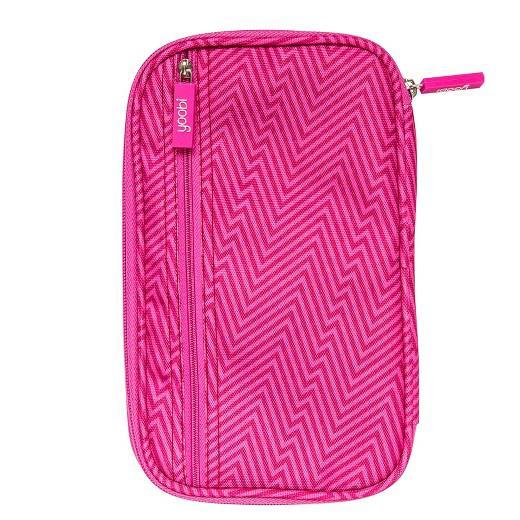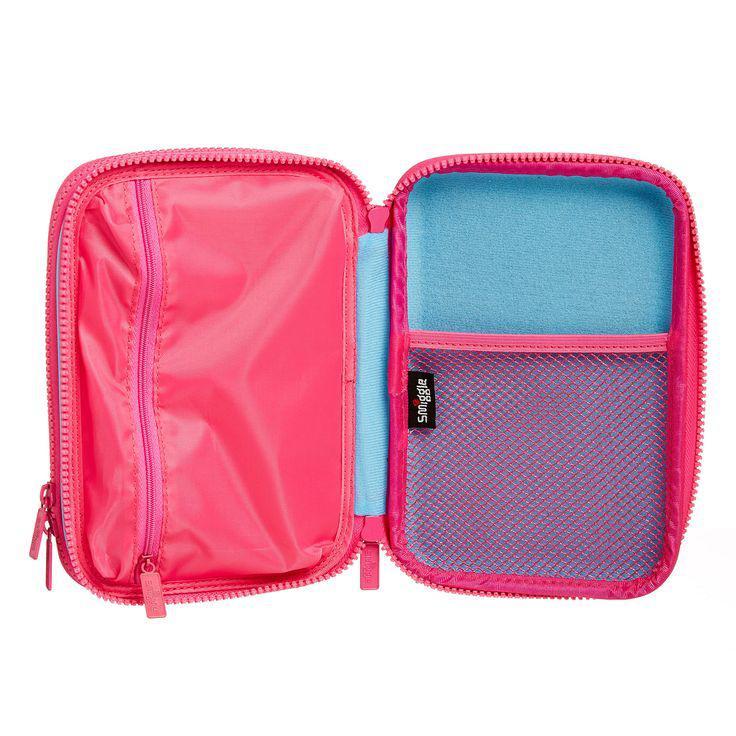The first image is the image on the left, the second image is the image on the right. For the images displayed, is the sentence "Each image shows one zipper pencil case with rounded corners, and the cases in the left and right images are shown in the same position and configuration." factually correct? Answer yes or no. No. The first image is the image on the left, the second image is the image on the right. Considering the images on both sides, is "One of the images shows a pink pencil case opened to reveal a blue lining on one side." valid? Answer yes or no. Yes. 